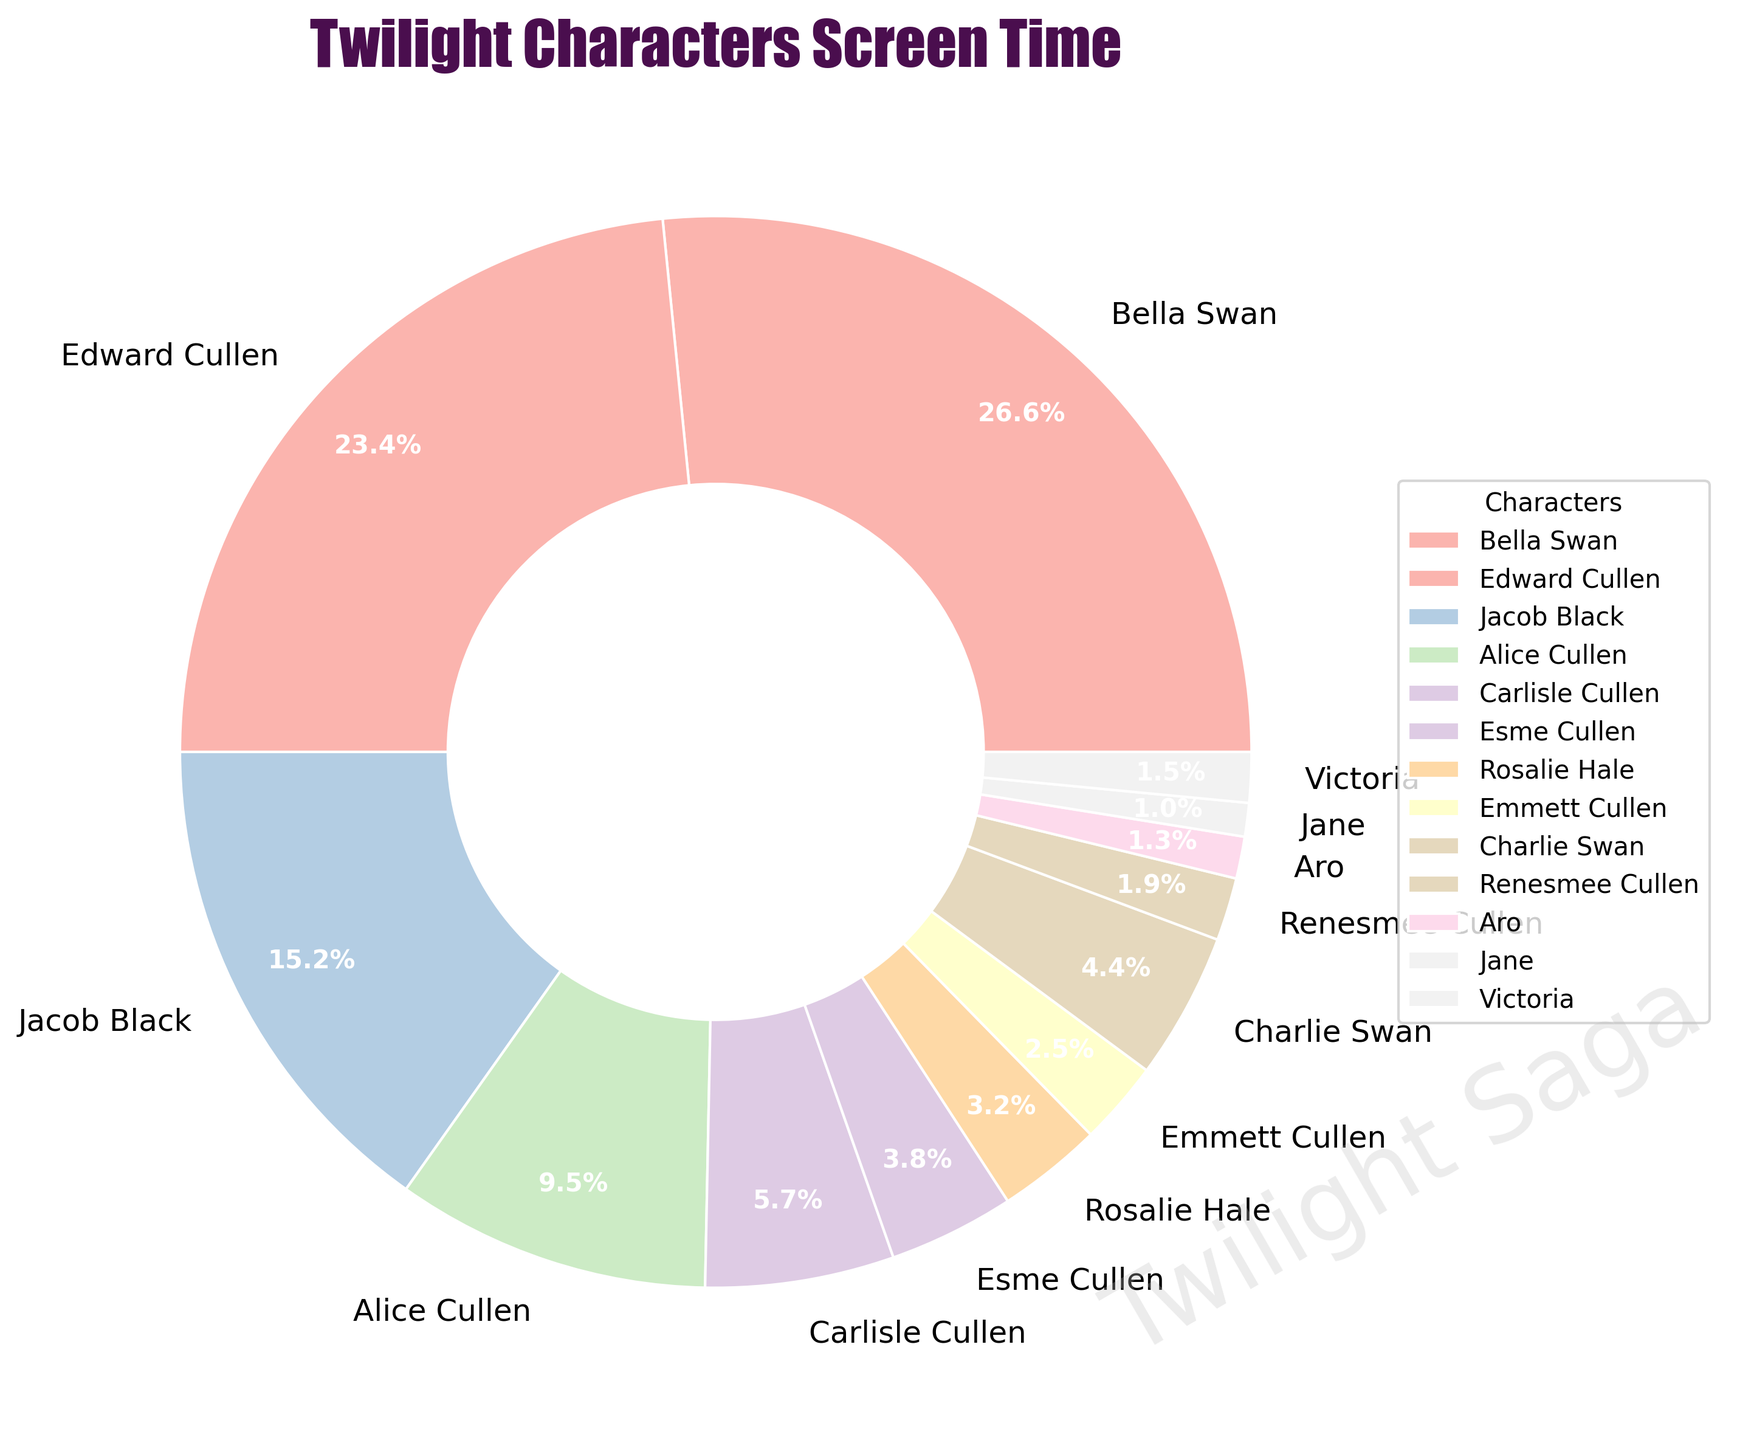What percentage of the total screen time is spent on Bella Swan? Bella Swan's screen time is represented on the pie chart. To find the percentage, we can look at the slice labeled "Bella Swan." According to the chart, she has 210 minutes of screen time. The total screen time is the sum of all characters' screen times, which is 720 minutes. Therefore, Bella's percentage is (210 / 720) * 100 = 29.2%.
Answer: 29.2% Who has more screen time between Alice Cullen and Jacob Black, and by how much? By looking at the pie chart, we see that Alice Cullen has 75 minutes and Jacob Black has 120 minutes of screen time. To find the difference: 120 (Jacob) - 75 (Alice) = 45 minutes.
Answer: Jacob Black, 45 minutes Which character has the smallest slice, and what is the exact screen time? To find the character with the smallest slice, we look for the smallest labeled slice on the pie chart. Jane has the smallest piece. The chart indicates she has 8 minutes of screen time.
Answer: Jane, 8 minutes What's the combined screen time of the Cullen family (Edward, Alice, Carlisle, Esme, Rosalie, Emmett, and Renesmee)? Add the individual screen times for all mentioned characters: Edward (185) + Alice (75) + Carlisle (45) + Esme (30) + Rosalie (25) + Emmett (20) + Renesmee (15) = 395 minutes.
Answer: 395 minutes Compare the screen time between Bella and Edward. Is there a significant difference? Bella has 210 minutes, and Edward has 185 minutes of screen time. The difference is 210 - 185 = 25 minutes. Considering the total time, the difference is not significant.
Answer: No, the difference is 25 minutes Which characters have more than 10% of the total screen time? To determine this, we can look at characters with slices greater than 10% on the chart. Bella (29.2%) and Edward (25.7%) each have more than 10% of the screen time.
Answer: Bella Swan and Edward Cullen How does the screen time of Charlie Swan compare to Renesmee Cullen? Charlie Swan has 35 minutes, and Renesmee Cullen has 15 minutes of screen time. The difference is 35 - 15 = 20 minutes. Charlie has significantly more screen time compared to Renesmee.
Answer: Charlie Swan has 20 minutes more What's the total screen time of characters with individual screen times less than 50 minutes? Look at each character with less than 50 minutes and sum their times: Carlisle (45) + Esme (30) + Rosalie (25) + Emmett (20) + Charlie (35) + Renesmee (15) + Aro (10) + Jane (8) + Victoria (12) = 200 minutes.
Answer: 200 minutes Which two characters combined have a screen time closest to Alice Cullen's screen time? Alice Cullen's screen time is 75 minutes. We need to find two characters whose sum is closest to 75. Esme (30) and Rosalie (25) combined: 30 + 25 = 55. Adding Emmett (20) gets 55 + 20 = 75, which matches perfectly.
Answer: Esme Cullen and Emmett Cullen Is the screen time of the major characters (Bella, Edward, Jacob) more than half of the total screen time? Adding screen times of Bella (210), Edward (185), and Jacob (120) gives us 515 minutes. The total screen time is 720 minutes. Half of the total is 360 minutes. So, 515 > 360, indicating the major characters' screen time is more than half.
Answer: Yes 